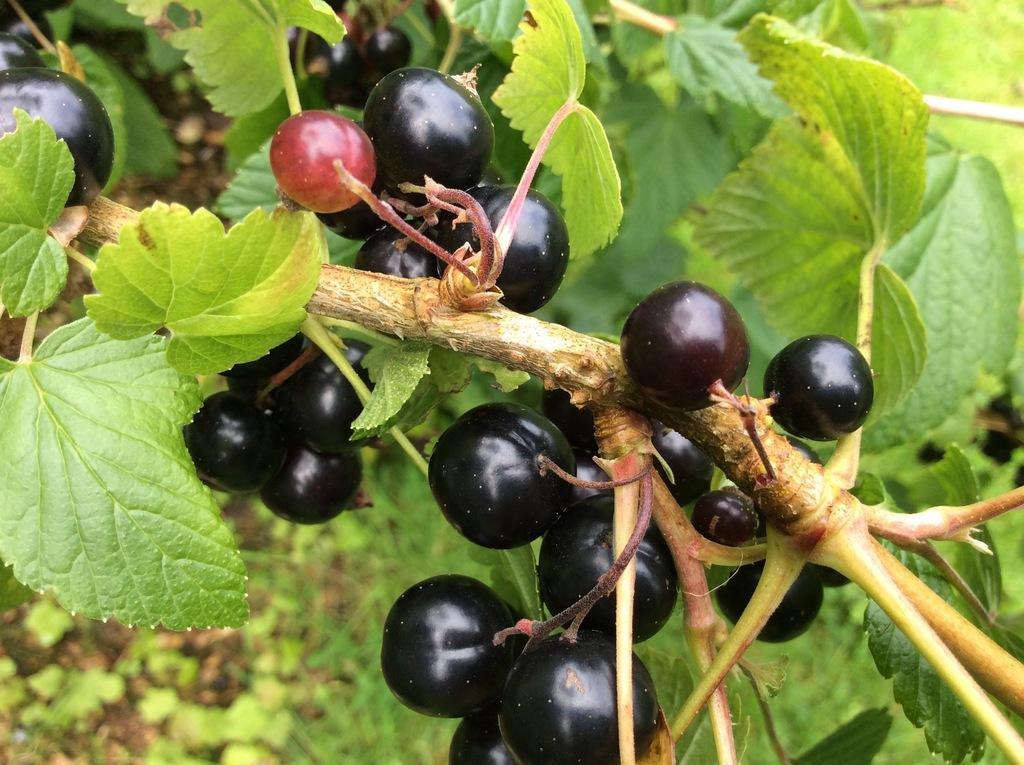Describe this image in one or two sentences. In this image, we can see some black color seedless fruits and we can see some green leaves. 